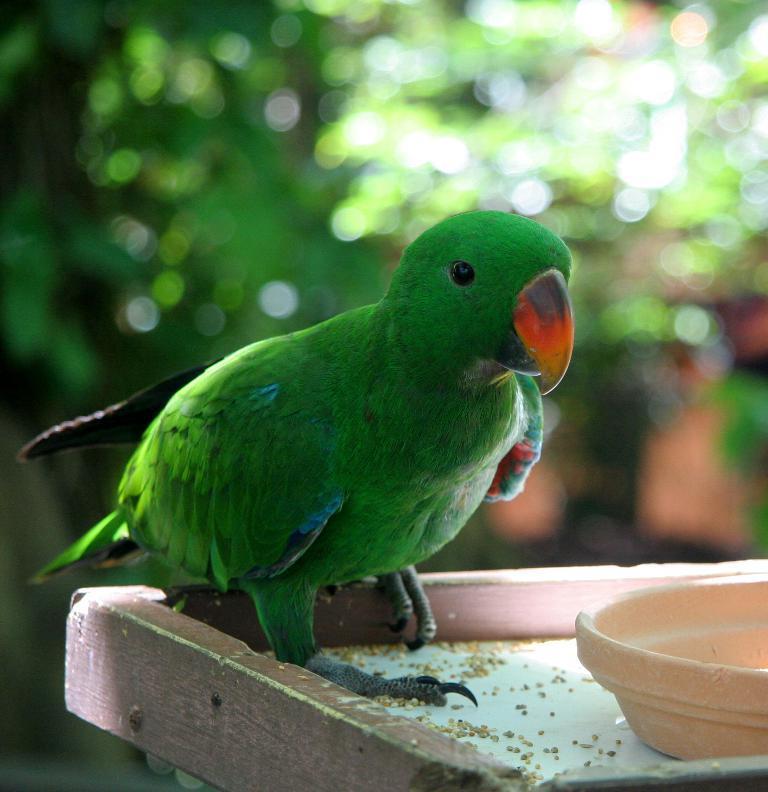Describe this image in one or two sentences. In the image in the center there is a table. On the table, we can see one bowl, one parrot, which is in green color and we can see some food particles. In the background we can see trees. 